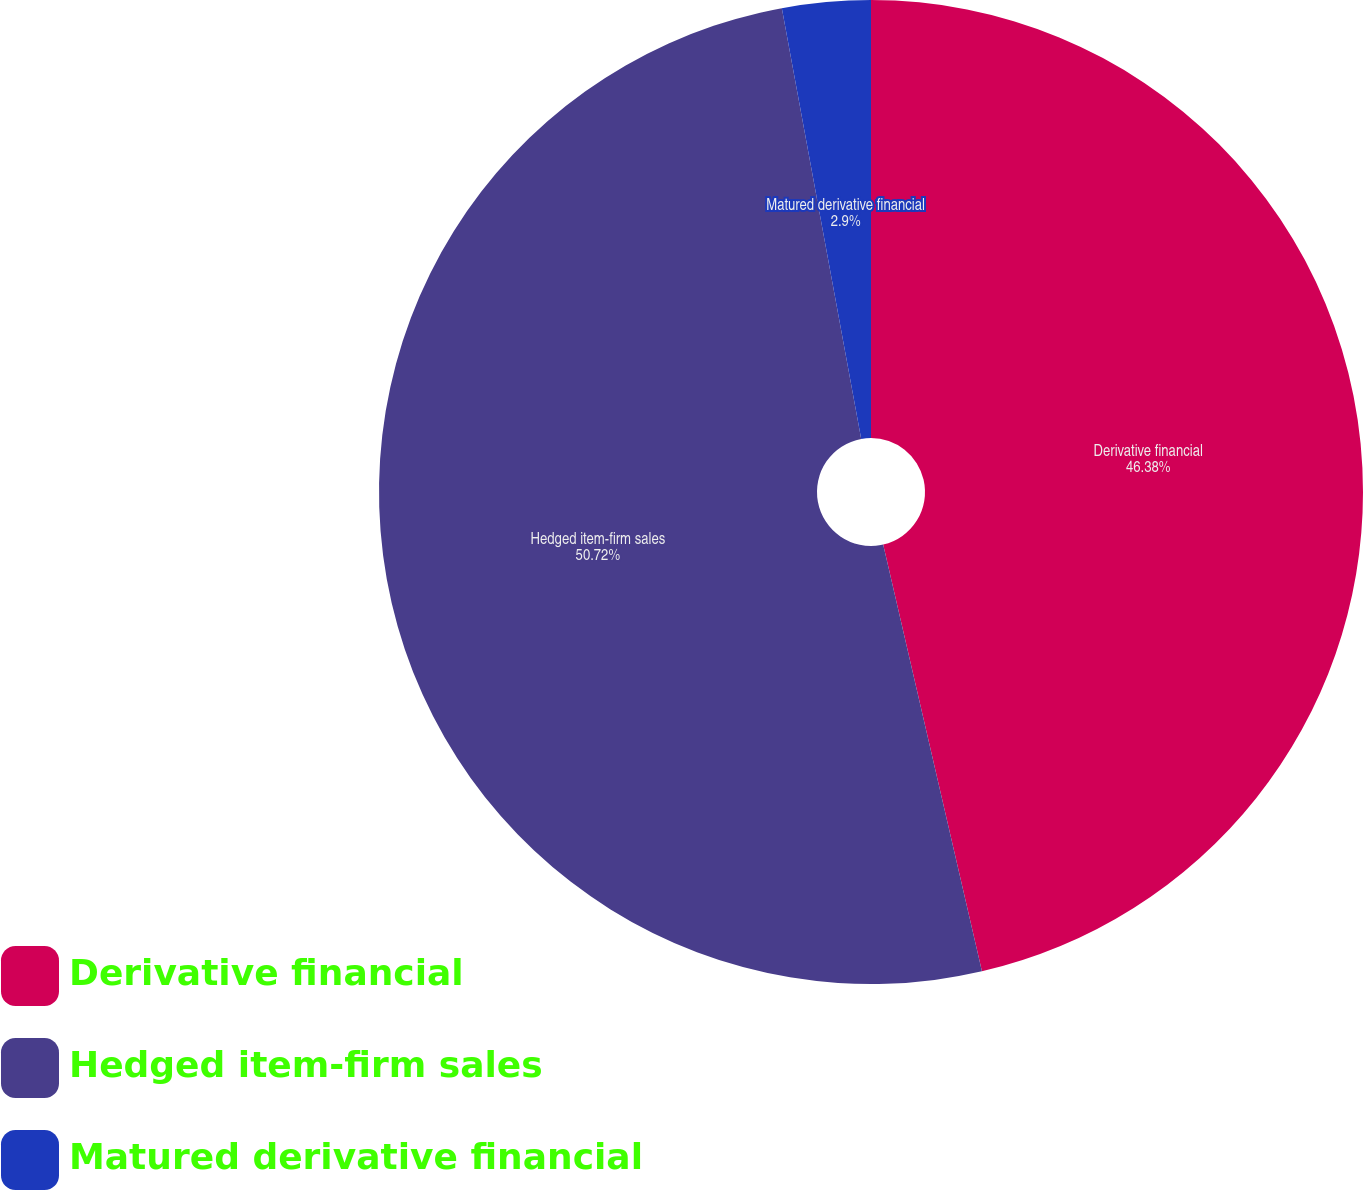Convert chart to OTSL. <chart><loc_0><loc_0><loc_500><loc_500><pie_chart><fcel>Derivative financial<fcel>Hedged item-firm sales<fcel>Matured derivative financial<nl><fcel>46.38%<fcel>50.72%<fcel>2.9%<nl></chart> 